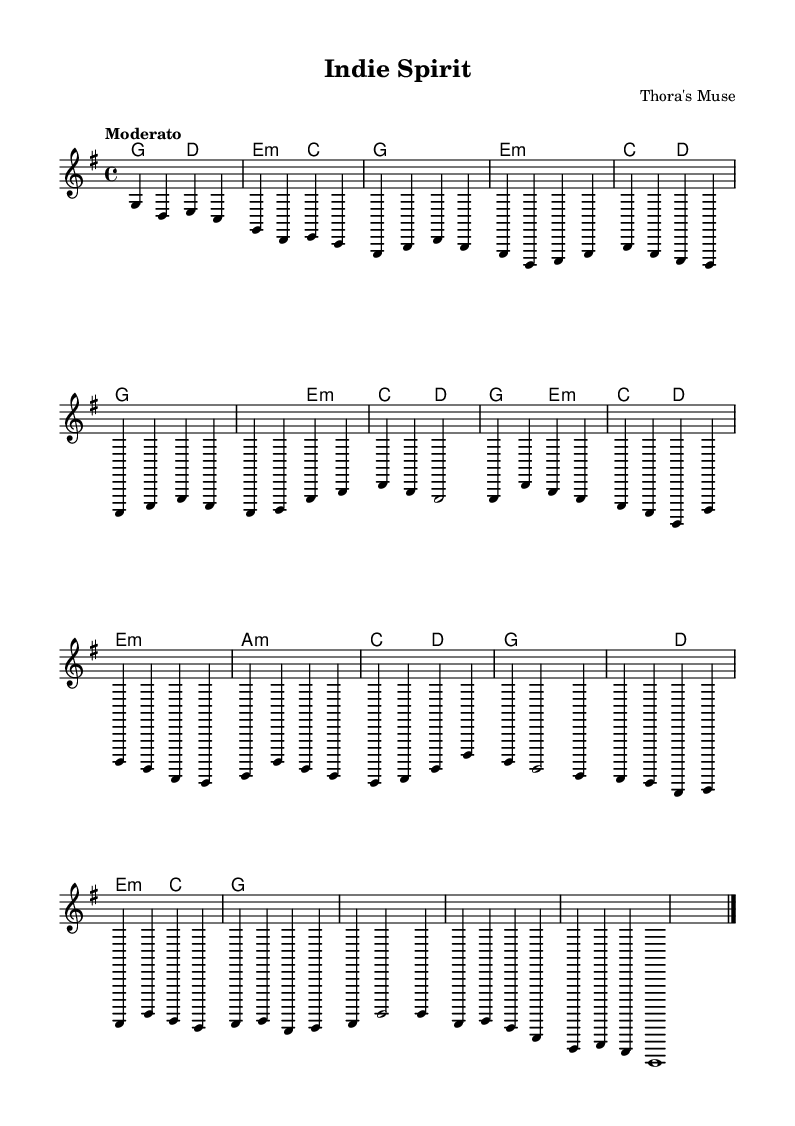What is the key signature of this music? The key signature is G major, which has one sharp (F#). This can be determined by looking at the key signature notation at the beginning of the sheet music.
Answer: G major What is the time signature of this music? The time signature is four-four time (4/4), as indicated in the sheet music. This means there are four beats in each measure and the quarter note gets one beat.
Answer: Four-four What is the tempo marking of this piece? The tempo marking is "Moderato," which suggests a moderate speed for the performance. This can be found in the tempo indication at the beginning.
Answer: Moderato How many measures are in the chorus section? The chorus consists of four measures. By counting the measures within the identified chorus section labeled in the sheet music, we can confirm this.
Answer: Four What type of guitar technique is primarily used throughout this piece? The piece primarily uses standard fingerpicking techniques, common in acoustic guitar compositions. This can be inferred from the notation style and phrasing across the sheet music.
Answer: Fingerpicking What is the final note in the outro of the piece? The final note in the outro is G. This is determined by looking at the last note indicated in the outro section of the sheet music, which ends on G.
Answer: G What is the harmonic progression used in the verse section? The harmonic progression in the verse follows a G - Em - C - D pattern. This can be deduced by analyzing the chord symbols provided in the harmony section during the verse.
Answer: G - Em - C - D 